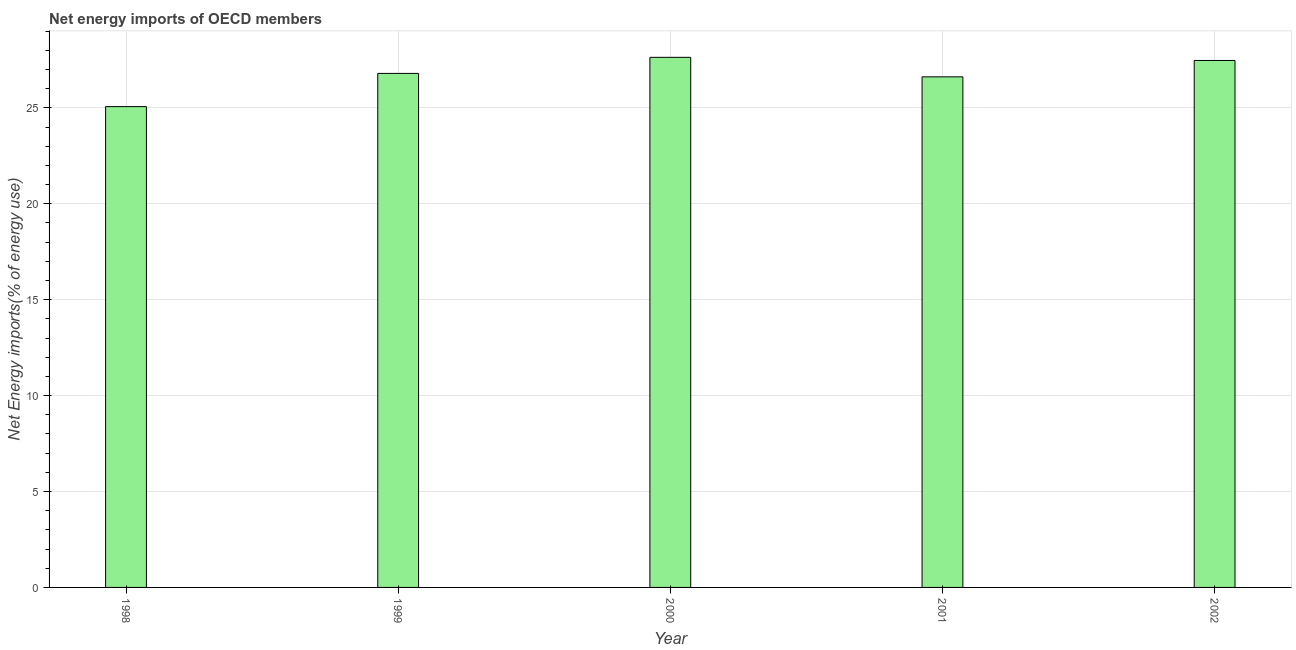What is the title of the graph?
Your response must be concise. Net energy imports of OECD members. What is the label or title of the Y-axis?
Offer a terse response. Net Energy imports(% of energy use). What is the energy imports in 2001?
Ensure brevity in your answer.  26.62. Across all years, what is the maximum energy imports?
Your answer should be compact. 27.63. Across all years, what is the minimum energy imports?
Offer a very short reply. 25.06. In which year was the energy imports maximum?
Provide a succinct answer. 2000. What is the sum of the energy imports?
Ensure brevity in your answer.  133.58. What is the difference between the energy imports in 2001 and 2002?
Offer a very short reply. -0.85. What is the average energy imports per year?
Offer a terse response. 26.71. What is the median energy imports?
Your response must be concise. 26.8. In how many years, is the energy imports greater than 9 %?
Provide a succinct answer. 5. What is the ratio of the energy imports in 1998 to that in 2000?
Make the answer very short. 0.91. Is the difference between the energy imports in 1999 and 2000 greater than the difference between any two years?
Offer a very short reply. No. What is the difference between the highest and the second highest energy imports?
Offer a terse response. 0.16. Is the sum of the energy imports in 1998 and 1999 greater than the maximum energy imports across all years?
Offer a very short reply. Yes. What is the difference between the highest and the lowest energy imports?
Ensure brevity in your answer.  2.57. Are all the bars in the graph horizontal?
Make the answer very short. No. How many years are there in the graph?
Your response must be concise. 5. Are the values on the major ticks of Y-axis written in scientific E-notation?
Your answer should be compact. No. What is the Net Energy imports(% of energy use) in 1998?
Keep it short and to the point. 25.06. What is the Net Energy imports(% of energy use) of 1999?
Make the answer very short. 26.8. What is the Net Energy imports(% of energy use) of 2000?
Make the answer very short. 27.63. What is the Net Energy imports(% of energy use) in 2001?
Keep it short and to the point. 26.62. What is the Net Energy imports(% of energy use) of 2002?
Provide a short and direct response. 27.47. What is the difference between the Net Energy imports(% of energy use) in 1998 and 1999?
Make the answer very short. -1.73. What is the difference between the Net Energy imports(% of energy use) in 1998 and 2000?
Offer a very short reply. -2.57. What is the difference between the Net Energy imports(% of energy use) in 1998 and 2001?
Give a very brief answer. -1.55. What is the difference between the Net Energy imports(% of energy use) in 1998 and 2002?
Keep it short and to the point. -2.41. What is the difference between the Net Energy imports(% of energy use) in 1999 and 2000?
Offer a terse response. -0.84. What is the difference between the Net Energy imports(% of energy use) in 1999 and 2001?
Offer a very short reply. 0.18. What is the difference between the Net Energy imports(% of energy use) in 1999 and 2002?
Provide a succinct answer. -0.67. What is the difference between the Net Energy imports(% of energy use) in 2000 and 2001?
Your answer should be compact. 1.02. What is the difference between the Net Energy imports(% of energy use) in 2000 and 2002?
Make the answer very short. 0.16. What is the difference between the Net Energy imports(% of energy use) in 2001 and 2002?
Make the answer very short. -0.85. What is the ratio of the Net Energy imports(% of energy use) in 1998 to that in 1999?
Make the answer very short. 0.94. What is the ratio of the Net Energy imports(% of energy use) in 1998 to that in 2000?
Make the answer very short. 0.91. What is the ratio of the Net Energy imports(% of energy use) in 1998 to that in 2001?
Ensure brevity in your answer.  0.94. What is the ratio of the Net Energy imports(% of energy use) in 1998 to that in 2002?
Make the answer very short. 0.91. What is the ratio of the Net Energy imports(% of energy use) in 1999 to that in 2000?
Provide a short and direct response. 0.97. What is the ratio of the Net Energy imports(% of energy use) in 2000 to that in 2001?
Keep it short and to the point. 1.04. 